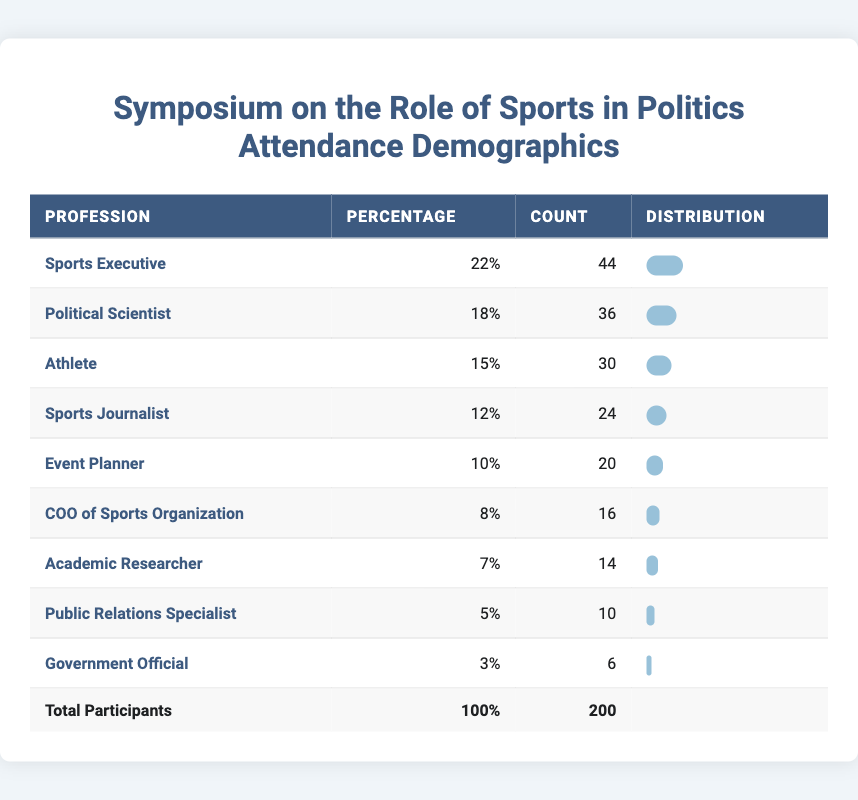What is the profession with the highest percentage of attendees? The highest percentage of attendees is for the profession "Sports Executive," which has a percentage of 22%.
Answer: Sports Executive How many participants are there in total from the profession of Athlete? The table indicates that there are 30 participants categorized as Athletes.
Answer: 30 What percentage of participants are either Sports Journalists or Athletes combined? To find the combined percentage, we add the percentages: 12% (Sports Journalists) + 15% (Athletes) = 27%.
Answer: 27% Is the count of Government Officials higher than that of Public Relations Specialists? The count of Government Officials is 6 while the count of Public Relations Specialists is 10; therefore, it is false.
Answer: No What is the difference in attendance count between Sports Executives and Academic Researchers? The attendance count for Sports Executives is 44, and for Academic Researchers, it is 14. The difference is calculated as 44 - 14 = 30.
Answer: 30 How many total participants are represented by the professions that make up at least 10% of the attendees? The professions are Sports Executive (44), Political Scientist (36), Athlete (30), and Sports Journalist (24). Their total count is 44 + 36 + 30 + 24 = 134.
Answer: 134 What percentage of participants are from the profession of COO of Sports Organization? The table shows that the percentage for the COO of Sports Organization is 8%.
Answer: 8% Are more participants classified as Event Planners than as Government Officials? The attendance count for Event Planners is 20, while for Government Officials, it is 6. Thus, it is true that there are more Event Planners.
Answer: Yes 